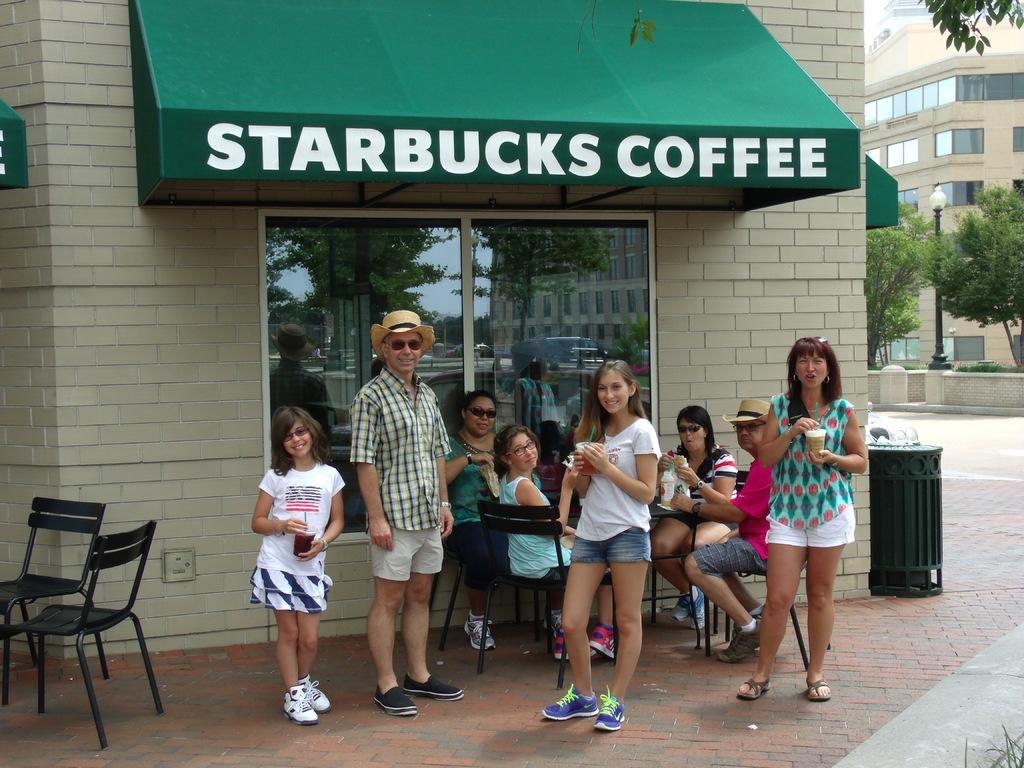Describe this image in one or two sentences. As we can see in the image there is a wall, building, trees, road and few people standing and sitting on chairs and there is a table over here. 